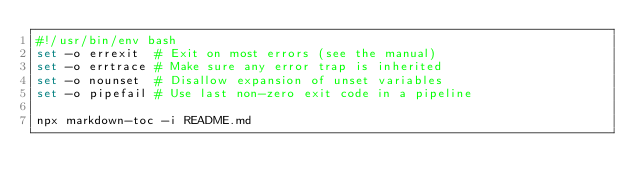Convert code to text. <code><loc_0><loc_0><loc_500><loc_500><_Bash_>#!/usr/bin/env bash
set -o errexit  # Exit on most errors (see the manual)
set -o errtrace # Make sure any error trap is inherited
set -o nounset  # Disallow expansion of unset variables
set -o pipefail # Use last non-zero exit code in a pipeline

npx markdown-toc -i README.md
</code> 